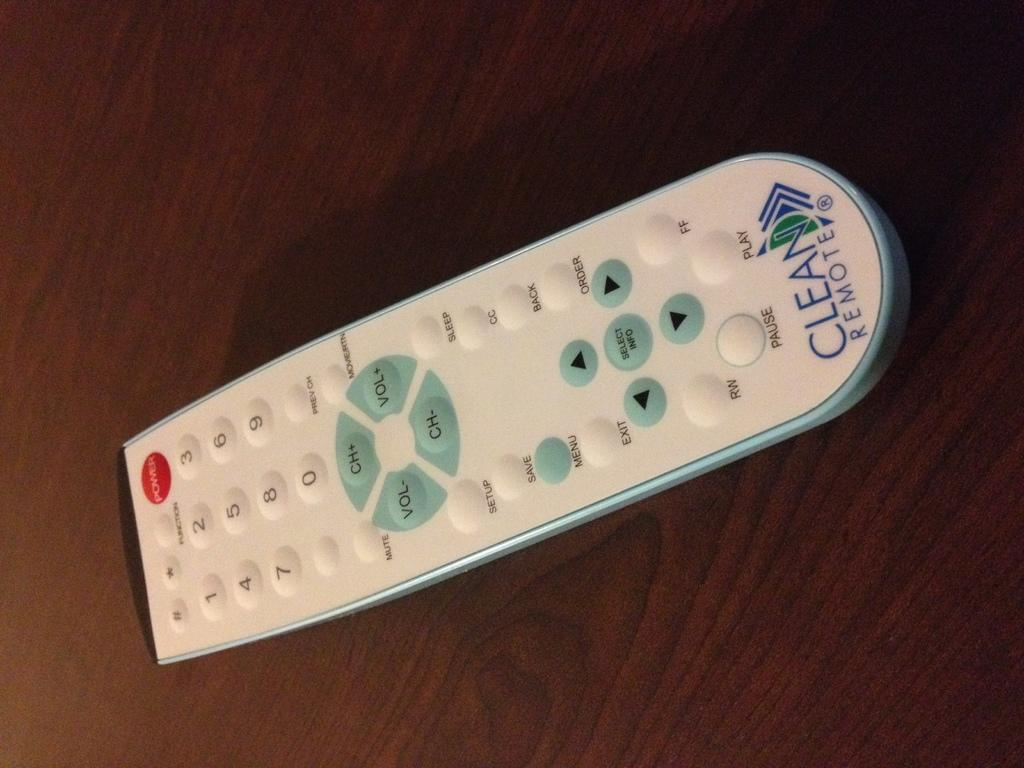<image>
Create a compact narrative representing the image presented. A Clean Remote, which is the make, is white and seen laying on a wooden surface. 